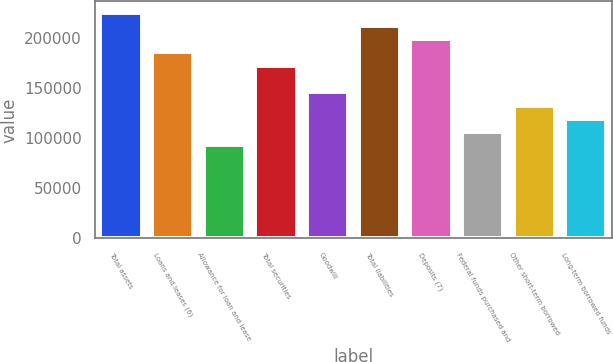Convert chart. <chart><loc_0><loc_0><loc_500><loc_500><bar_chart><fcel>Total assets<fcel>Loans and leases (6)<fcel>Allowance for loan and lease<fcel>Total securities<fcel>Goodwill<fcel>Total liabilities<fcel>Deposits (7)<fcel>Federal funds purchased and<fcel>Other short-term borrowed<fcel>Long-term borrowed funds<nl><fcel>225856<fcel>185999<fcel>93000.2<fcel>172714<fcel>146143<fcel>212570<fcel>199285<fcel>106286<fcel>132857<fcel>119571<nl></chart> 